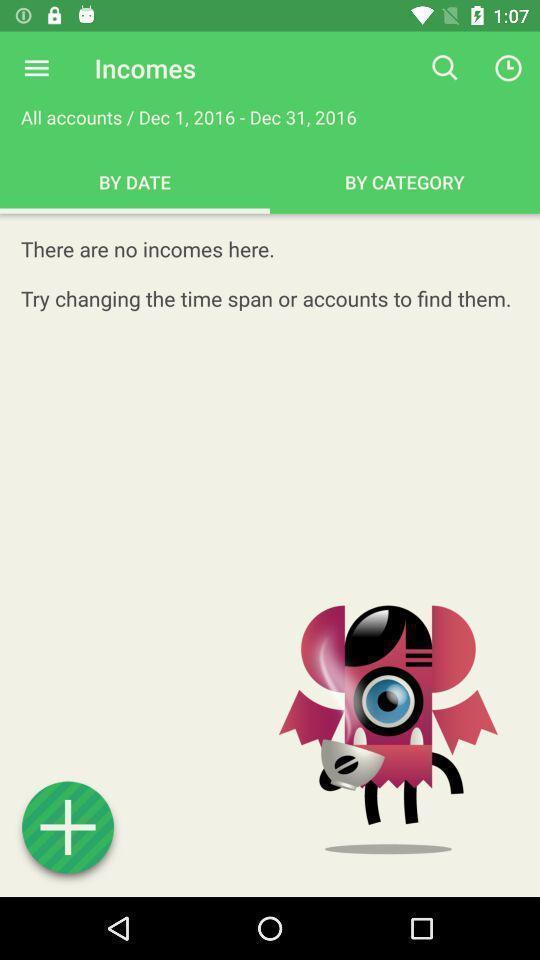Describe the visual elements of this screenshot. Page displaying with no incomes and with add-on option. 